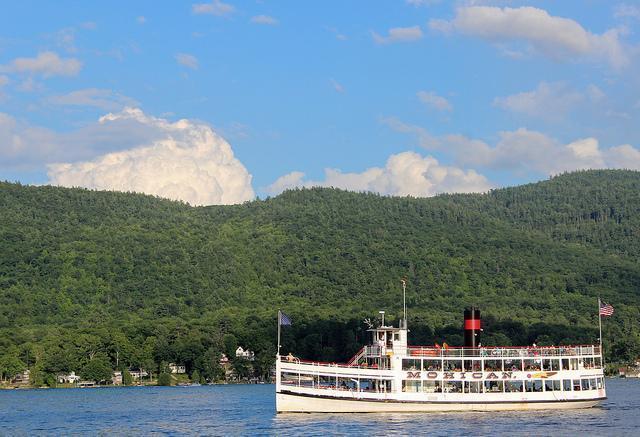Who is on the boat?
Select the accurate answer and provide justification: `Answer: choice
Rationale: srationale.`
Options: Escapees, convicts, tourists, swimmers. Answer: tourists.
Rationale: This is a boat that is used for leisure, and for these purposes, it is most likely utilized by tourists. 